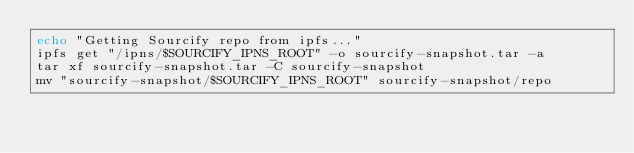Convert code to text. <code><loc_0><loc_0><loc_500><loc_500><_Bash_>echo "Getting Sourcify repo from ipfs..."
ipfs get "/ipns/$SOURCIFY_IPNS_ROOT" -o sourcify-snapshot.tar -a
tar xf sourcify-snapshot.tar -C sourcify-snapshot
mv "sourcify-snapshot/$SOURCIFY_IPNS_ROOT" sourcify-snapshot/repo
</code> 